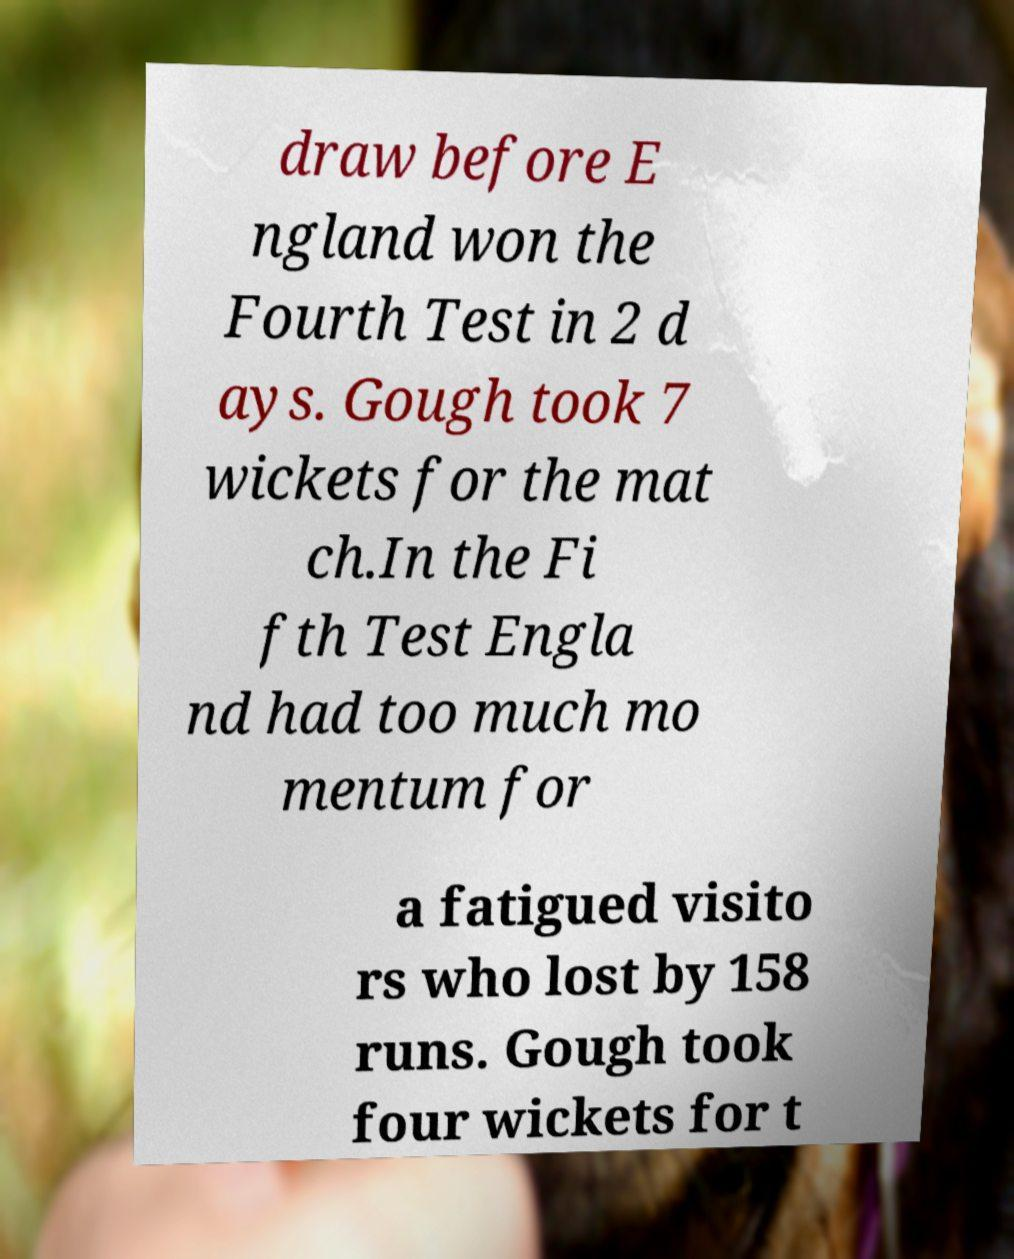Could you assist in decoding the text presented in this image and type it out clearly? draw before E ngland won the Fourth Test in 2 d ays. Gough took 7 wickets for the mat ch.In the Fi fth Test Engla nd had too much mo mentum for a fatigued visito rs who lost by 158 runs. Gough took four wickets for t 